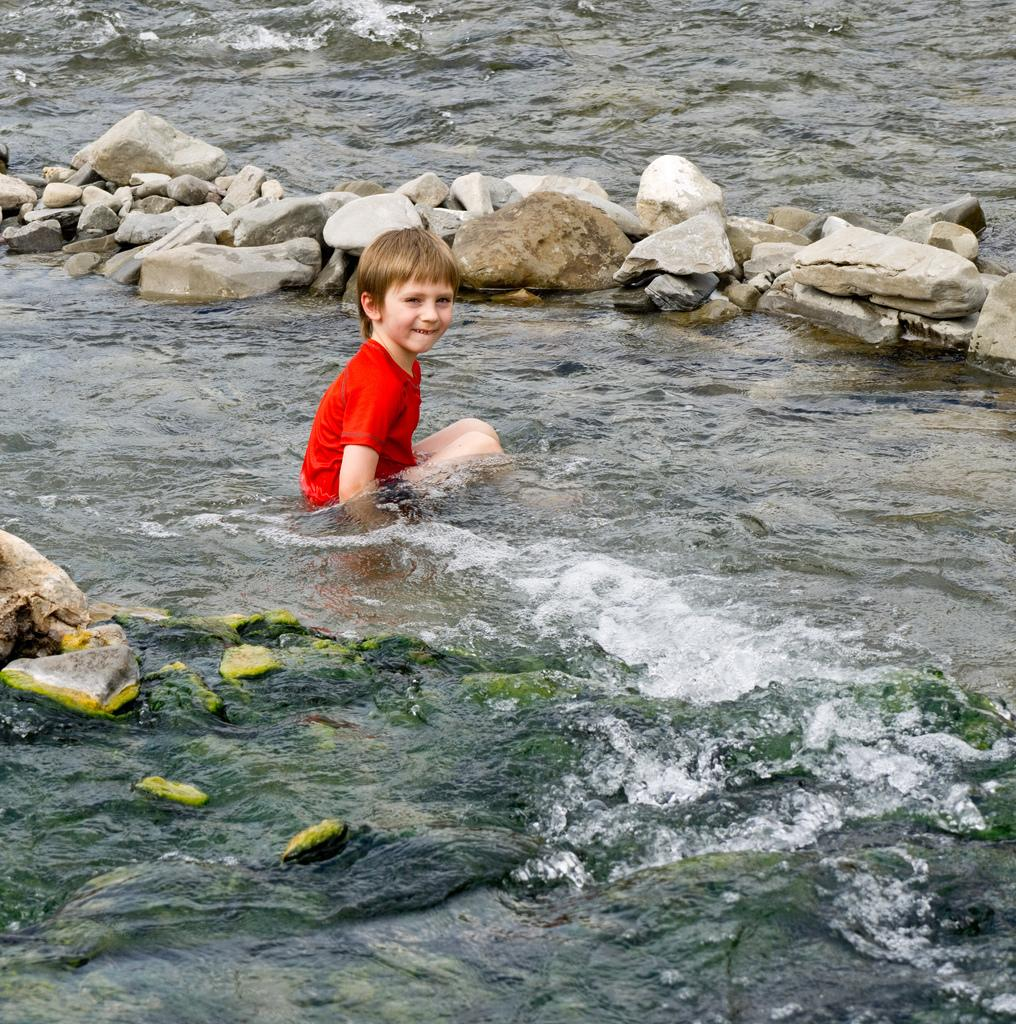What is the main subject of the image? There is a kid in the water in the center of the image. What can be seen at the top of the image? There are stones at the top of the image. Where are more stones located in the image? There are stones on the left side of the image. What is happening with the water in the image? Water is flowing in the image. How does the wind affect the water flow in the image? There is no mention of wind in the image, so we cannot determine its effect on the water flow. 